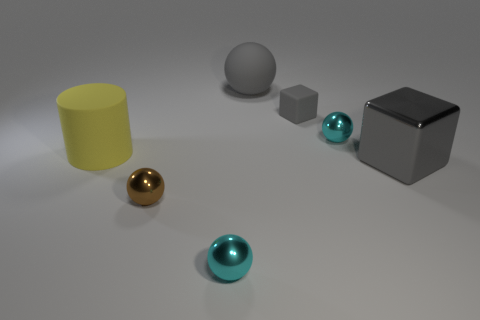The cylinder is what color?
Give a very brief answer. Yellow. What number of green matte things are the same shape as the brown metal thing?
Your answer should be very brief. 0. What is the color of the metal block that is the same size as the gray sphere?
Provide a succinct answer. Gray. Are any gray shiny cylinders visible?
Offer a very short reply. No. There is a small metallic thing behind the big yellow cylinder; what shape is it?
Your response must be concise. Sphere. What number of spheres are in front of the rubber ball and left of the tiny gray block?
Your answer should be very brief. 2. Are there any small purple cylinders that have the same material as the tiny brown ball?
Offer a terse response. No. The matte block that is the same color as the large ball is what size?
Your answer should be very brief. Small. How many balls are either cyan metal objects or brown metallic things?
Provide a short and direct response. 3. What size is the gray ball?
Provide a succinct answer. Large. 